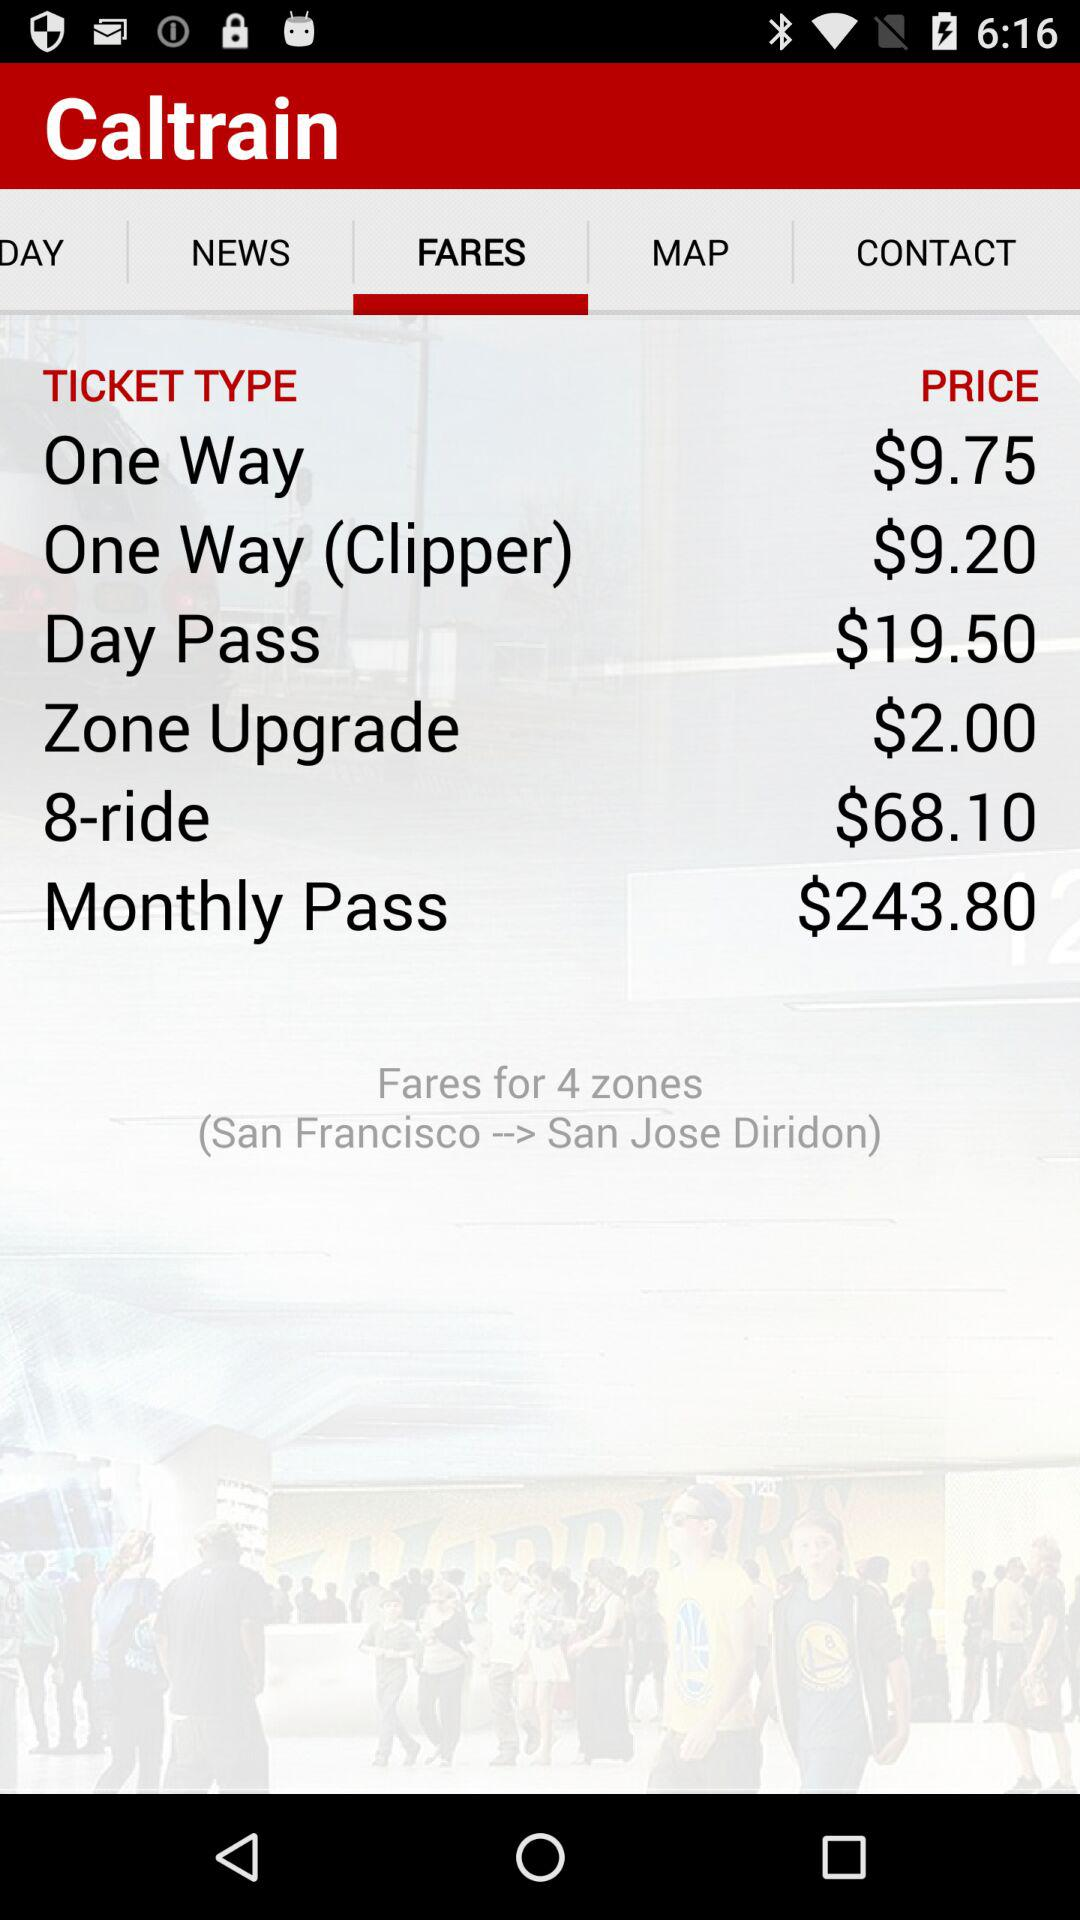What is the name of the application? The name of the application is "Caltrain". 